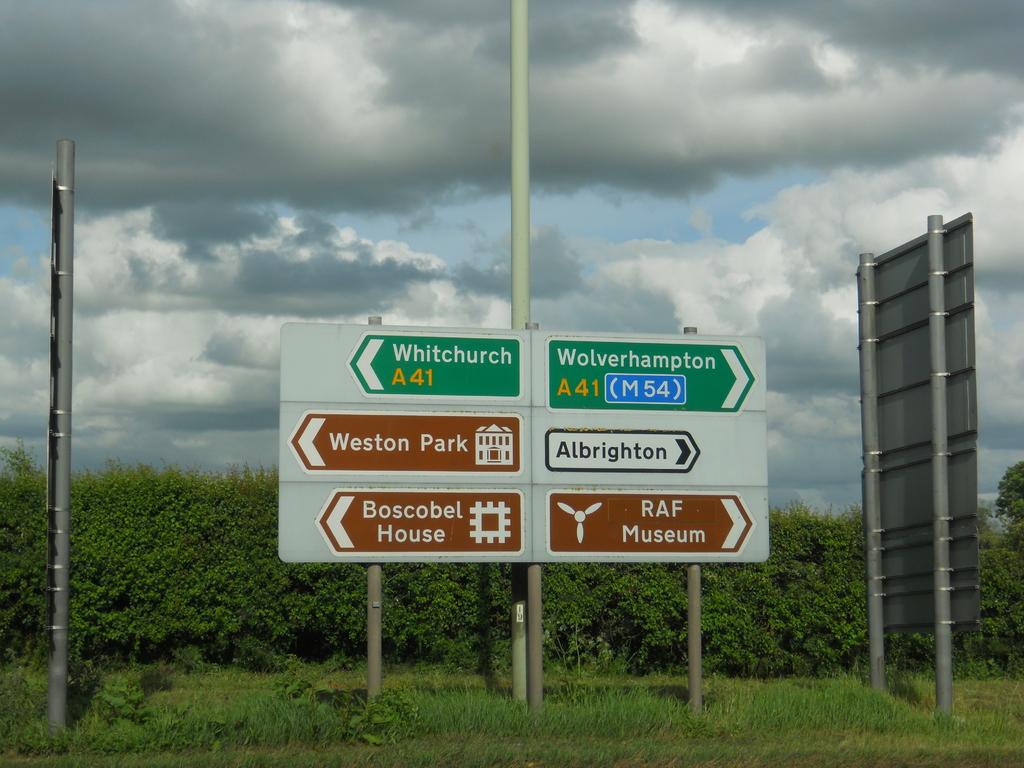Where do these routes lead?
Keep it short and to the point. Unanswerable. What museum can be found to the right?
Give a very brief answer. Raf. 